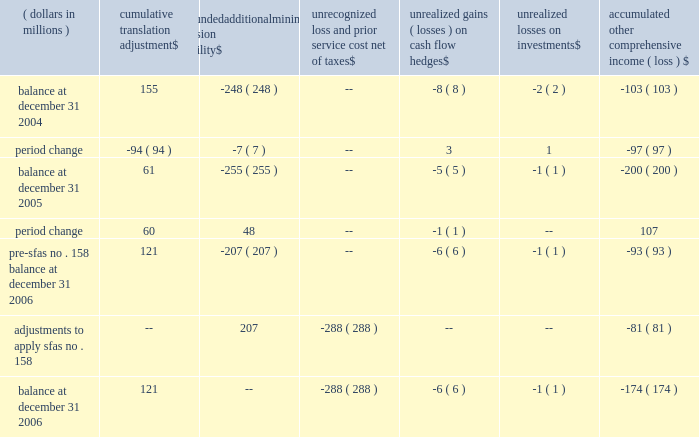Eastman notes to the audited consolidated financial statements accumulated other comprehensive income ( loss ) ( dollars in millions ) cumulative translation adjustment unfunded additional minimum pension liability unrecognized loss and prior service cost , net of unrealized gains ( losses ) on cash flow hedges unrealized losses on investments accumulated comprehensive income ( loss ) balance at december 31 , 2004 155 ( 248 ) -- ( 8 ) ( 2 ) ( 103 ) .
Pre-sfas no .
158 balance at december 31 , 2006 121 ( 207 ) -- ( 6 ) ( 1 ) ( 93 ) adjustments to apply sfas no .
158 -- 207 ( 288 ) -- -- ( 81 ) balance at december 31 , 2006 121 -- ( 288 ) ( 6 ) ( 1 ) ( 174 ) except for cumulative translation adjustment , amounts of other comprehensive income ( loss ) are presented net of applicable taxes .
Because cumulative translation adjustment is considered a component of permanently invested , unremitted earnings of subsidiaries outside the united states , no taxes are provided on such amounts .
15 .
Share-based compensation plans and awards 2002 omnibus long-term compensation plan eastman's 2002 omnibus long-term compensation plan provides for grants to employees of nonqualified stock options , incentive stock options , tandem and freestanding stock appreciation rights ( 201csar 2019s 201d ) , performance shares and various other stock and stock-based awards .
The 2002 omnibus plan provides that options can be granted through may 2 , 2007 , for the purchase of eastman common stock at an option price not less than 100 percent of the per share fair market value on the date of the stock option's grant .
There is a maximum of 7.5 million shares of common stock available for option grants and other awards during the term of the 2002 omnibus plan .
Director long-term compensation plan eastman's 2002 director long-term compensation plan provides for grants of nonqualified stock options and restricted shares to nonemployee members of the board of directors .
Shares of restricted stock are granted upon the first day of the directors' initial term of service and nonqualified stock options and shares of restricted stock are granted each year following the annual meeting of stockholders .
The 2002 director plan provides that options can be granted through the later of may 1 , 2007 , or the date of the annual meeting of stockholders in 2007 for the purchase of eastman common stock at an option price not less than the stock's fair market value on the date of the grant. .
What was the sum of the cumulative translation adjustments from 2004 to 2006? 
Computations: (-94 + 60)
Answer: -34.0. 